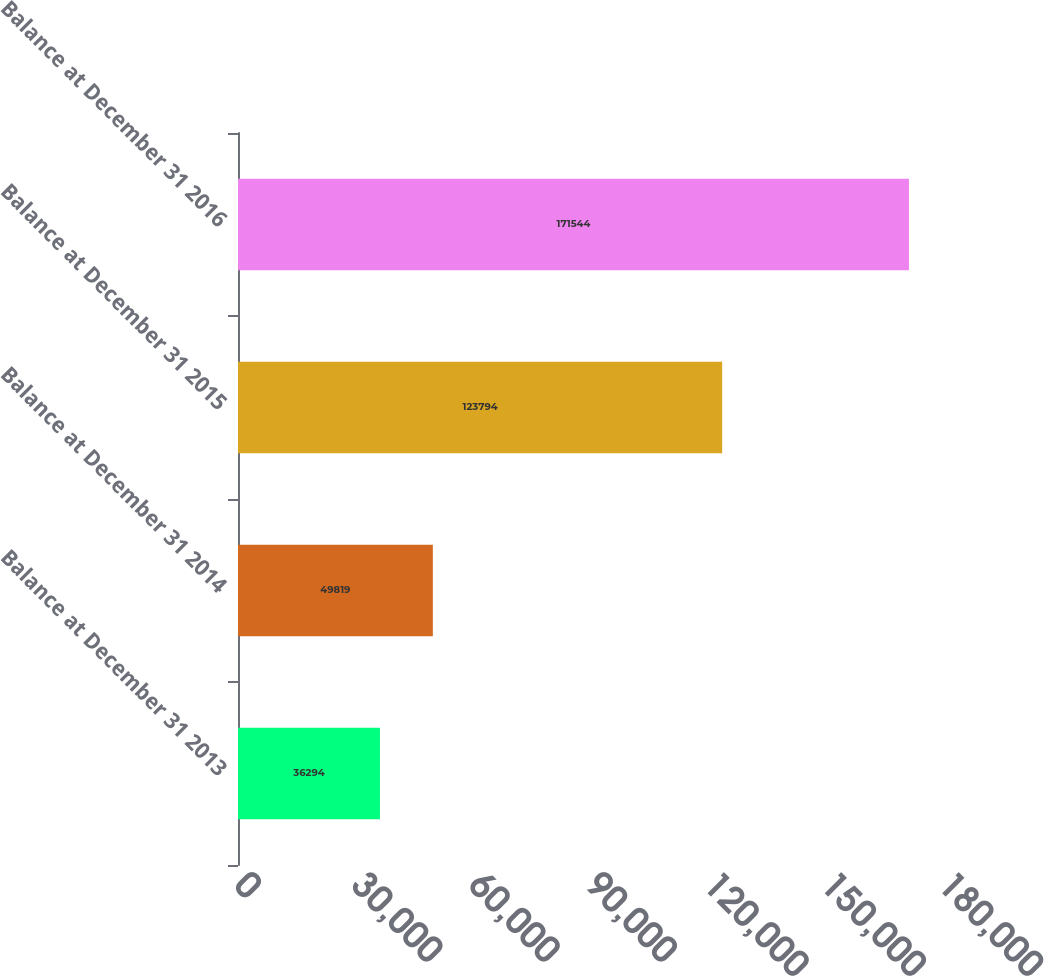Convert chart to OTSL. <chart><loc_0><loc_0><loc_500><loc_500><bar_chart><fcel>Balance at December 31 2013<fcel>Balance at December 31 2014<fcel>Balance at December 31 2015<fcel>Balance at December 31 2016<nl><fcel>36294<fcel>49819<fcel>123794<fcel>171544<nl></chart> 